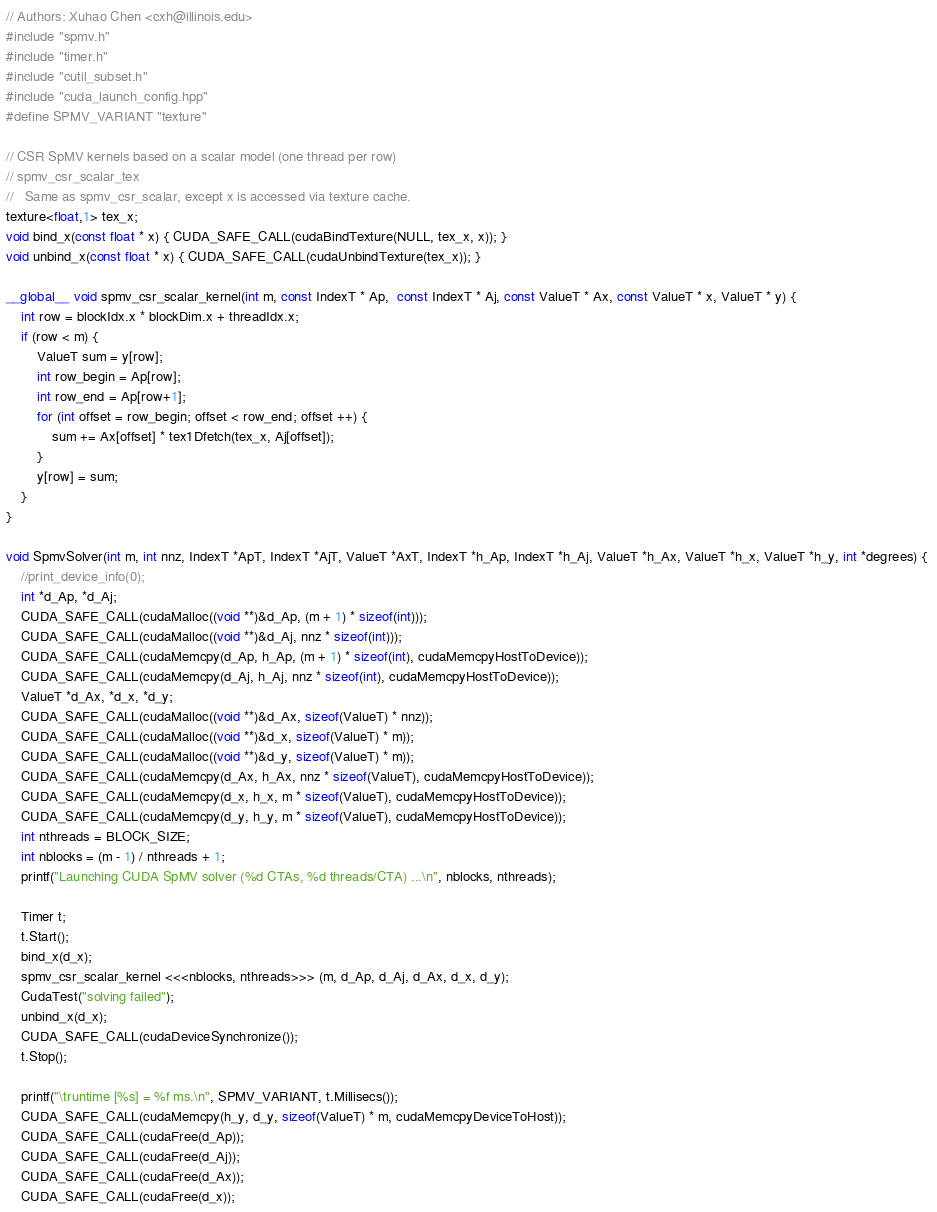Convert code to text. <code><loc_0><loc_0><loc_500><loc_500><_Cuda_>// Authors: Xuhao Chen <cxh@illinois.edu>
#include "spmv.h"
#include "timer.h"
#include "cutil_subset.h"
#include "cuda_launch_config.hpp"
#define SPMV_VARIANT "texture"

// CSR SpMV kernels based on a scalar model (one thread per row)
// spmv_csr_scalar_tex
//   Same as spmv_csr_scalar, except x is accessed via texture cache.
texture<float,1> tex_x;
void bind_x(const float * x) { CUDA_SAFE_CALL(cudaBindTexture(NULL, tex_x, x)); }
void unbind_x(const float * x) { CUDA_SAFE_CALL(cudaUnbindTexture(tex_x)); }

__global__ void spmv_csr_scalar_kernel(int m, const IndexT * Ap,  const IndexT * Aj, const ValueT * Ax, const ValueT * x, ValueT * y) {
	int row = blockIdx.x * blockDim.x + threadIdx.x;
	if (row < m) {
		ValueT sum = y[row];
		int row_begin = Ap[row];
		int row_end = Ap[row+1];
		for (int offset = row_begin; offset < row_end; offset ++) {
			sum += Ax[offset] * tex1Dfetch(tex_x, Aj[offset]);
		}
		y[row] = sum;
	}
}

void SpmvSolver(int m, int nnz, IndexT *ApT, IndexT *AjT, ValueT *AxT, IndexT *h_Ap, IndexT *h_Aj, ValueT *h_Ax, ValueT *h_x, ValueT *h_y, int *degrees) { 
	//print_device_info(0);
	int *d_Ap, *d_Aj;
	CUDA_SAFE_CALL(cudaMalloc((void **)&d_Ap, (m + 1) * sizeof(int)));
	CUDA_SAFE_CALL(cudaMalloc((void **)&d_Aj, nnz * sizeof(int)));
	CUDA_SAFE_CALL(cudaMemcpy(d_Ap, h_Ap, (m + 1) * sizeof(int), cudaMemcpyHostToDevice));
	CUDA_SAFE_CALL(cudaMemcpy(d_Aj, h_Aj, nnz * sizeof(int), cudaMemcpyHostToDevice));
	ValueT *d_Ax, *d_x, *d_y;
	CUDA_SAFE_CALL(cudaMalloc((void **)&d_Ax, sizeof(ValueT) * nnz));
	CUDA_SAFE_CALL(cudaMalloc((void **)&d_x, sizeof(ValueT) * m));
	CUDA_SAFE_CALL(cudaMalloc((void **)&d_y, sizeof(ValueT) * m));
	CUDA_SAFE_CALL(cudaMemcpy(d_Ax, h_Ax, nnz * sizeof(ValueT), cudaMemcpyHostToDevice));
	CUDA_SAFE_CALL(cudaMemcpy(d_x, h_x, m * sizeof(ValueT), cudaMemcpyHostToDevice));
	CUDA_SAFE_CALL(cudaMemcpy(d_y, h_y, m * sizeof(ValueT), cudaMemcpyHostToDevice));
	int nthreads = BLOCK_SIZE;
	int nblocks = (m - 1) / nthreads + 1;
	printf("Launching CUDA SpMV solver (%d CTAs, %d threads/CTA) ...\n", nblocks, nthreads);

	Timer t;
	t.Start();
	bind_x(d_x);
	spmv_csr_scalar_kernel <<<nblocks, nthreads>>> (m, d_Ap, d_Aj, d_Ax, d_x, d_y);   
	CudaTest("solving failed");
	unbind_x(d_x);
	CUDA_SAFE_CALL(cudaDeviceSynchronize());
	t.Stop();

	printf("\truntime [%s] = %f ms.\n", SPMV_VARIANT, t.Millisecs());
	CUDA_SAFE_CALL(cudaMemcpy(h_y, d_y, sizeof(ValueT) * m, cudaMemcpyDeviceToHost));
	CUDA_SAFE_CALL(cudaFree(d_Ap));
	CUDA_SAFE_CALL(cudaFree(d_Aj));
	CUDA_SAFE_CALL(cudaFree(d_Ax));
	CUDA_SAFE_CALL(cudaFree(d_x));</code> 